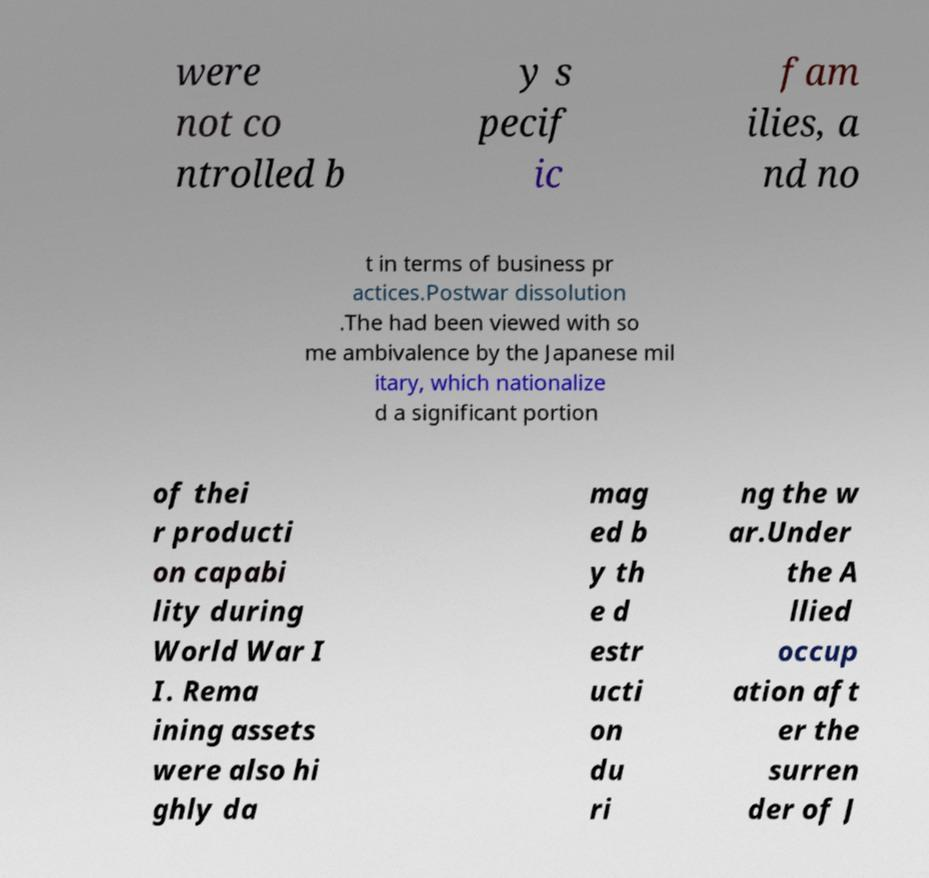Can you accurately transcribe the text from the provided image for me? were not co ntrolled b y s pecif ic fam ilies, a nd no t in terms of business pr actices.Postwar dissolution .The had been viewed with so me ambivalence by the Japanese mil itary, which nationalize d a significant portion of thei r producti on capabi lity during World War I I. Rema ining assets were also hi ghly da mag ed b y th e d estr ucti on du ri ng the w ar.Under the A llied occup ation aft er the surren der of J 